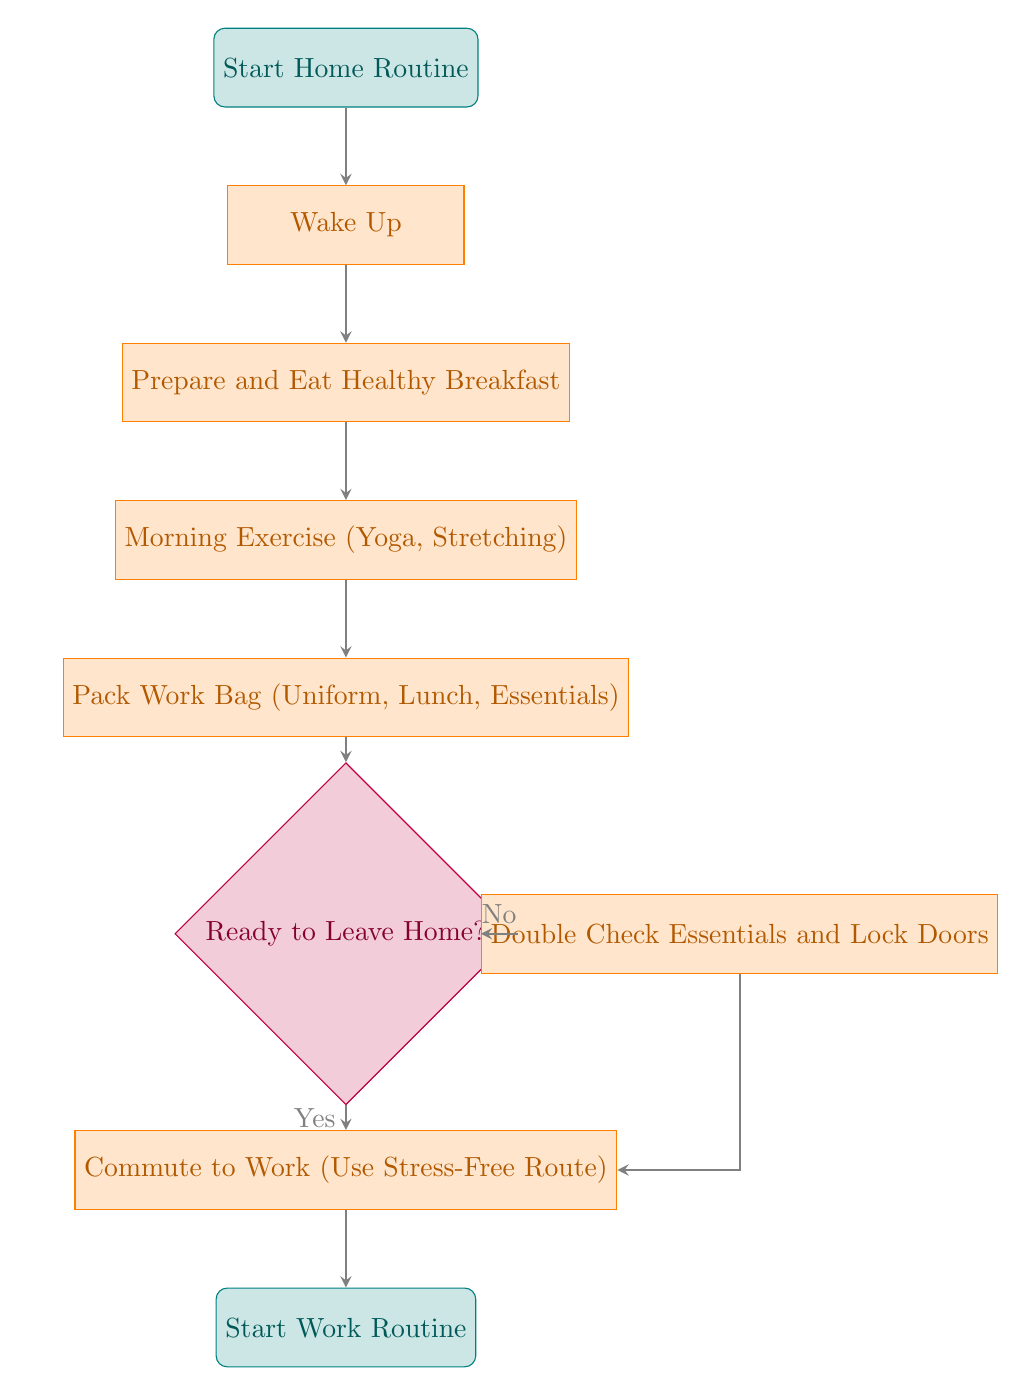What is the first step in this transition planner? The first step is indicated by the "Start Home Routine" node, which shows the beginning of the process.
Answer: Start Home Routine How many total process nodes are there in the diagram? The process nodes are "Wake Up," "Prepare and Eat Healthy Breakfast," "Morning Exercise (Yoga, Stretching)," "Pack Work Bag (Uniform, Lunch, Essentials)," and "Commute to Work (Use Stress-Free Route)." Counting these gives a total of 5 process nodes.
Answer: 5 What indicates a decision point in this flow chart? The decision point is indicated by the diamond-shaped node labeled "Ready to Leave Home?". This shape specifically denotes a point where a yes or no decision is required.
Answer: Ready to Leave Home? What happens if the answer to "Ready to Leave Home?" is No? If the answer is No, the flow moves to the "Double Check Essentials and Lock Doors" process, which is indicated as the next action after leaving the decision node in the diagram.
Answer: Double Check Essentials and Lock Doors What is the final step in this transition planner? The final step is indicated by the node labeled "Start Work Routine," showing the conclusion of the home-to-work transition.
Answer: Start Work Routine What is included in the process of packing the work bag? The process node for packing includes essentials like "Uniform, Lunch, Essentials," indicating what items should be packed before leaving.
Answer: Uniform, Lunch, Essentials How does the flow proceed from "Double Check Essentials and Lock Doors"? After "Double Check Essentials and Lock Doors," the flow returns to "Commute to Work (Use Stress-Free Route)" as indicated by the arrow leading from this process node back to the commuting step.
Answer: Commute to Work (Use Stress-Free Route) 